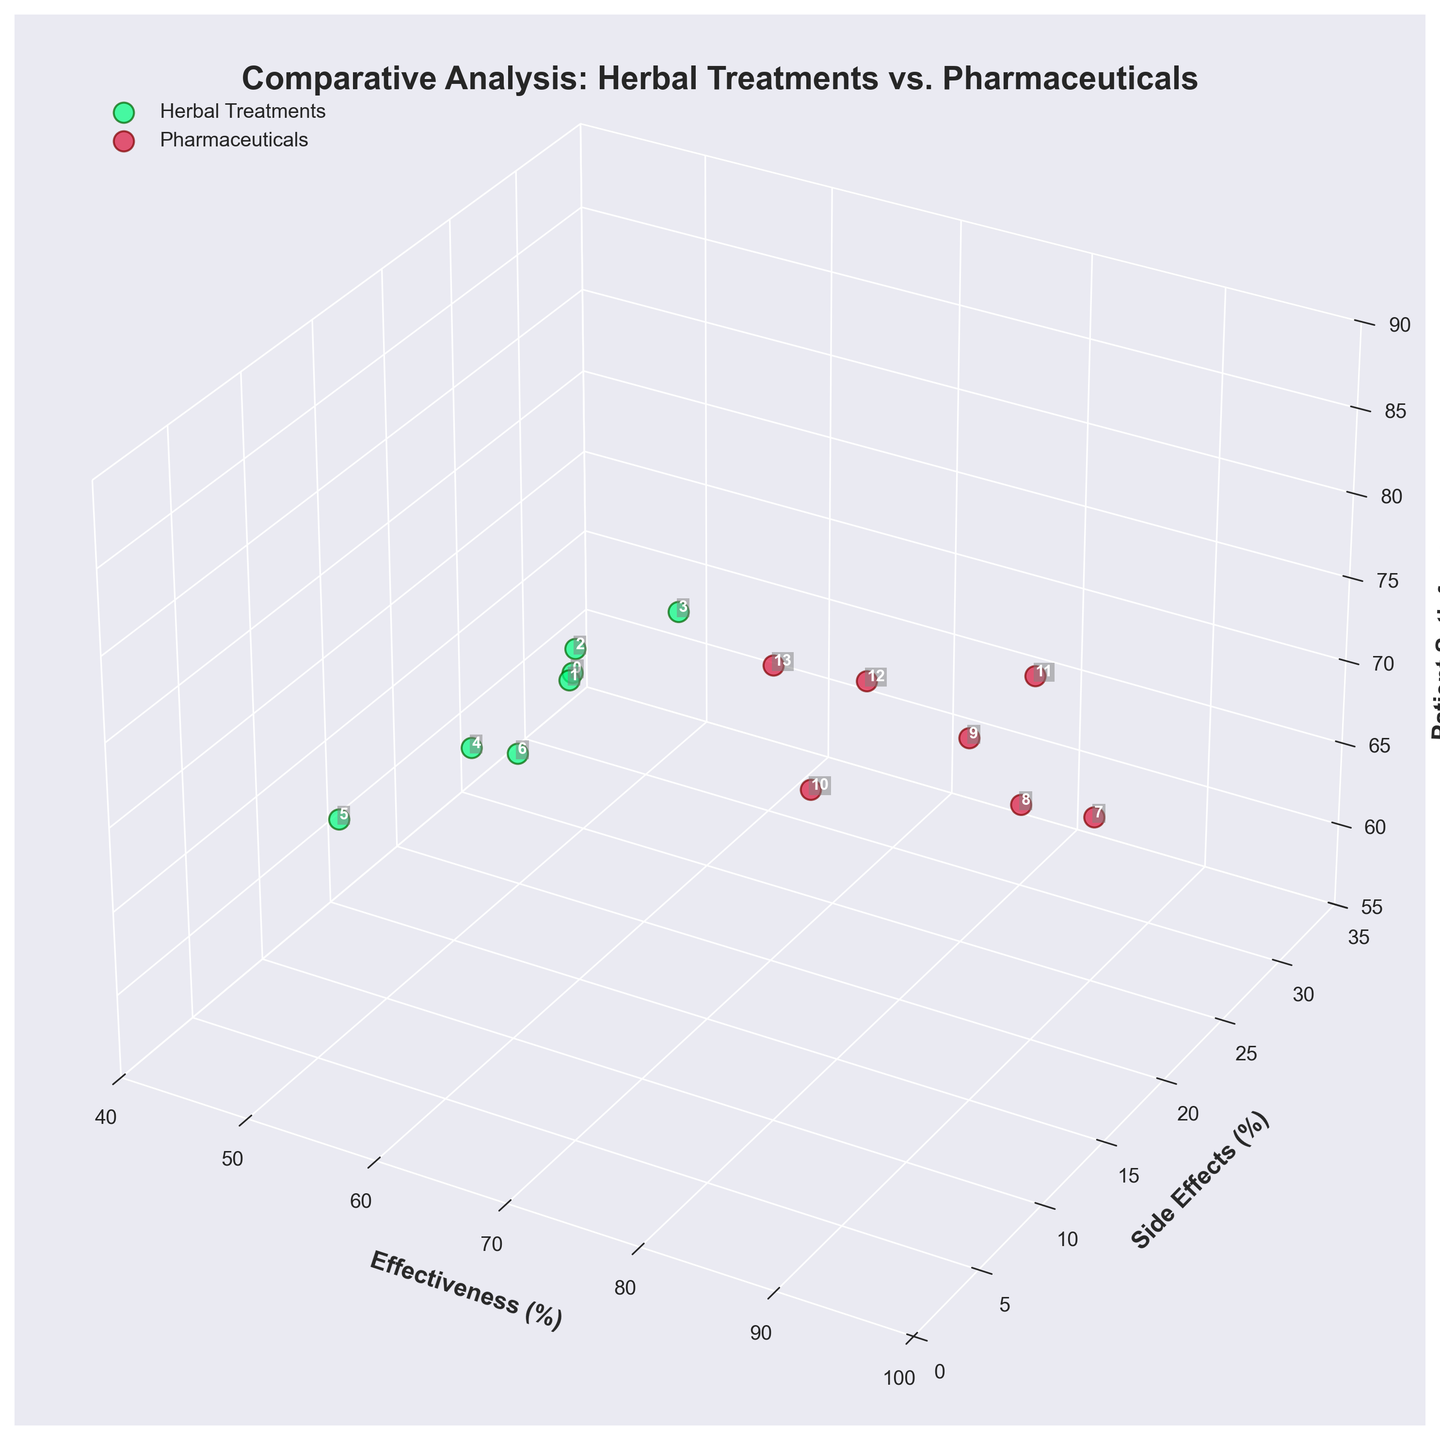What are the axis labels in the plot? The axis labels are "Effectiveness (%)" for the x-axis, "Side Effects (%)" for the y-axis, and "Patient Satisfaction (%)" for the z-axis. These labels indicate the metrics being compared across different treatments.
Answer: Effectiveness, Side Effects, Patient Satisfaction How many data points represent pharmaceutical treatments? The figure shows data points with two different colors: spring green for herbal treatments and crimson red for pharmaceuticals. Counting the red data points indicates the number of pharmaceutical treatments.
Answer: 7 Which treatment has the highest effectiveness? The effectiveness axis ranges from 40 to 100. By observing the data points along this axis, the highest value corresponds to the point representing Antibiotics.
Answer: Antibiotics How do the average side effects of herbal treatments compare to pharmaceutical treatments? Calculate the average side effects for each group. For herbal treatments, the values are 10, 5, 15, 8, 12, 7, and 6. For pharmaceuticals, the values are 25, 30, 20, 18, 22, 15, and 12. Average for herbal: (10+5+15+8+12+7+6)/7 = 9. Average for pharmaceuticals: (25+30+20+18+22+15+12)/7 = 20.29.
Answer: Herbal: 9, Pharmaceuticals: 20.29 Which treatment has the highest patient satisfaction rate among herbal treatments? Look at the patient satisfaction values for herbal treatments (green data points). The highest value in this group corresponds to Turmeric, with a satisfaction rate of 85.
Answer: Turmeric Is there any treatment with lower side effects and higher effectiveness than NSAIDs? NSAIDs have an effectiveness of 85 and side effects of 20. Compare these values with other treatments. Only Antibiotics have higher effectiveness (90) but also higher side effects (25). No other treatment meets both criteria.
Answer: No What is the relationship between side effects and patient satisfaction for Valerian Root? Valerian Root has side effects of 12% and patient satisfaction of 70%. This data point can be seen in the lower side-effects range with moderate patient satisfaction among the herbal treatments, suggesting higher side effects might correlate with lower satisfaction.
Answer: 12% side effects, 70% satisfaction Which pharmaceutical treatment has the closest patient satisfaction rate to Echinacea? Echinacea has a patient satisfaction rate of 78%. Among pharmaceutical treatments, Bronchodilators also have a satisfaction rate of 78%, making it the closest match.
Answer: Bronchodilators In general, do herbal treatments have higher or lower side effects compared to pharmaceuticals? By comparing the clusters of green (herbal) and red (pharmaceutical) data points along the side effects axis, it's observable that herbal treatments tend to cluster around lower side effect percentages compared to pharmaceuticals.
Answer: Lower Which treatment has the lowest difference between effectiveness and side effects? Calculate the difference for each treatment and compare. For example, Echinacea: 65 - 10 = 55, Ginger: 70 - 5 = 65, and so on. Among all treatments, Ginkgo Biloba has the smallest difference: 43 (50 - 7 = 43).
Answer: Ginkgo Biloba 